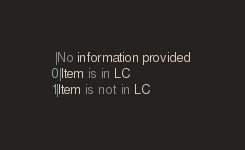<code> <loc_0><loc_0><loc_500><loc_500><_SQL_> |No information provided 
0|Item is in LC 
1|Item is not in LC 
</code> 